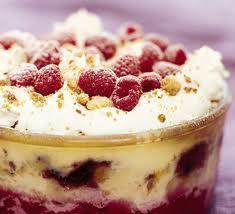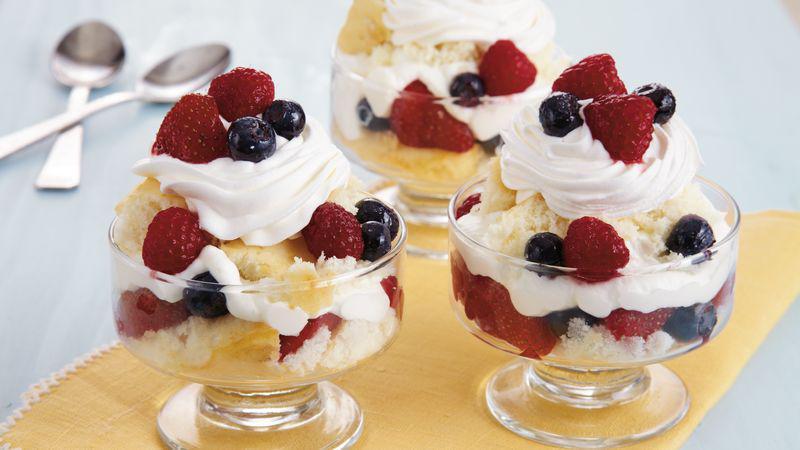The first image is the image on the left, the second image is the image on the right. Analyze the images presented: Is the assertion "All of the trifles are topped with blueberries or raspberries." valid? Answer yes or no. Yes. 